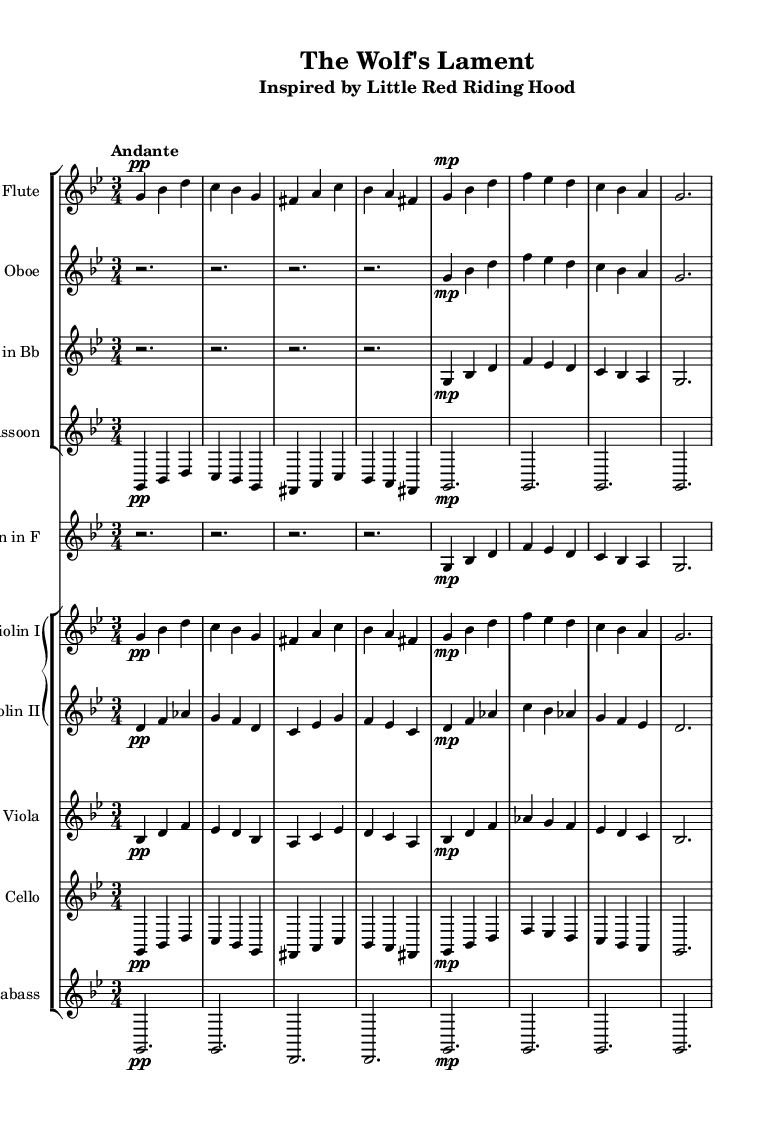What is the key signature of this music? The key signature is G minor, which includes two flats (B flat and E flat). This can be identified by looking at the key signature shown at the beginning of the score.
Answer: G minor What is the time signature? The time signature is 3/4, meaning there are three beats per measure. This can be seen in the time signature marking at the beginning of the score.
Answer: 3/4 What is the tempo marking for this piece? The tempo marking is "Andante", which indicates a moderate pace. It can be found above the staff indicating the speed of the music.
Answer: Andante How many measures are in the flute part? The flute part has 8 measures. By counting the groups of vertical lines (bar lines) in the flute staff, you can see there are 8 measures.
Answer: 8 Which instrument plays the melody in measures 1 and 8? The melody in measures 1 and 8 is played by the flute. You can identify this by looking at the flute staff where these measures are notated.
Answer: Flute What do the dynamics indicate at the beginning of the piece? The dynamics indicate pp, meaning "pianissimo" or very soft. This marking appears at the beginning of the flute part and is reflected throughout the piece.
Answer: pp Which fairy tale inspired this orchestral composition? The orchestral composition is inspired by "Little Red Riding Hood," as indicated in the subtitle of the score.
Answer: Little Red Riding Hood 